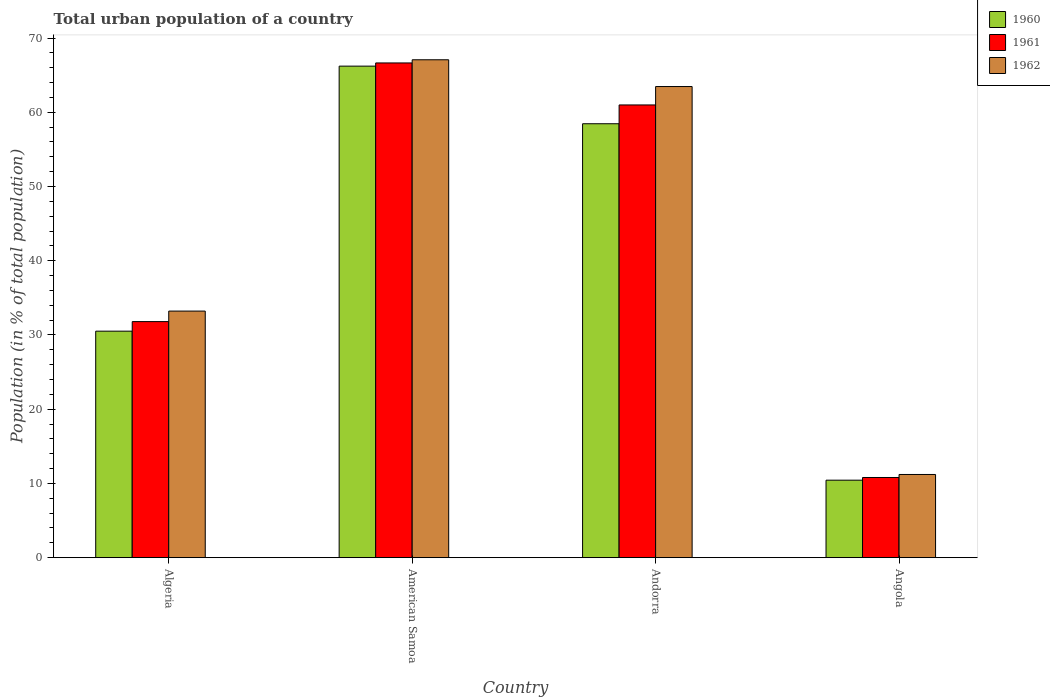How many different coloured bars are there?
Ensure brevity in your answer.  3. How many groups of bars are there?
Make the answer very short. 4. Are the number of bars per tick equal to the number of legend labels?
Your response must be concise. Yes. Are the number of bars on each tick of the X-axis equal?
Keep it short and to the point. Yes. How many bars are there on the 1st tick from the left?
Your answer should be compact. 3. What is the label of the 3rd group of bars from the left?
Offer a terse response. Andorra. In how many cases, is the number of bars for a given country not equal to the number of legend labels?
Offer a very short reply. 0. What is the urban population in 1960 in Algeria?
Make the answer very short. 30.51. Across all countries, what is the maximum urban population in 1960?
Your response must be concise. 66.21. Across all countries, what is the minimum urban population in 1962?
Your answer should be compact. 11.2. In which country was the urban population in 1960 maximum?
Your answer should be very brief. American Samoa. In which country was the urban population in 1962 minimum?
Keep it short and to the point. Angola. What is the total urban population in 1962 in the graph?
Your answer should be compact. 174.95. What is the difference between the urban population in 1961 in Algeria and that in Angola?
Ensure brevity in your answer.  21. What is the difference between the urban population in 1962 in Andorra and the urban population in 1961 in Algeria?
Offer a terse response. 31.67. What is the average urban population in 1961 per country?
Your response must be concise. 42.55. What is the difference between the urban population of/in 1962 and urban population of/in 1961 in American Samoa?
Ensure brevity in your answer.  0.43. In how many countries, is the urban population in 1961 greater than 50 %?
Your response must be concise. 2. What is the ratio of the urban population in 1961 in Algeria to that in Andorra?
Your answer should be compact. 0.52. What is the difference between the highest and the second highest urban population in 1961?
Make the answer very short. 5.66. What is the difference between the highest and the lowest urban population in 1960?
Provide a succinct answer. 55.78. In how many countries, is the urban population in 1960 greater than the average urban population in 1960 taken over all countries?
Give a very brief answer. 2. What does the 1st bar from the left in Algeria represents?
Your response must be concise. 1960. Is it the case that in every country, the sum of the urban population in 1961 and urban population in 1962 is greater than the urban population in 1960?
Give a very brief answer. Yes. How many countries are there in the graph?
Offer a very short reply. 4. Are the values on the major ticks of Y-axis written in scientific E-notation?
Ensure brevity in your answer.  No. Does the graph contain any zero values?
Provide a short and direct response. No. Where does the legend appear in the graph?
Offer a very short reply. Top right. How many legend labels are there?
Make the answer very short. 3. What is the title of the graph?
Your answer should be very brief. Total urban population of a country. Does "1994" appear as one of the legend labels in the graph?
Provide a short and direct response. No. What is the label or title of the Y-axis?
Your response must be concise. Population (in % of total population). What is the Population (in % of total population) in 1960 in Algeria?
Offer a very short reply. 30.51. What is the Population (in % of total population) of 1961 in Algeria?
Offer a terse response. 31.8. What is the Population (in % of total population) of 1962 in Algeria?
Make the answer very short. 33.21. What is the Population (in % of total population) of 1960 in American Samoa?
Provide a short and direct response. 66.21. What is the Population (in % of total population) of 1961 in American Samoa?
Offer a terse response. 66.64. What is the Population (in % of total population) in 1962 in American Samoa?
Provide a succinct answer. 67.07. What is the Population (in % of total population) in 1960 in Andorra?
Give a very brief answer. 58.45. What is the Population (in % of total population) in 1961 in Andorra?
Your response must be concise. 60.98. What is the Population (in % of total population) of 1962 in Andorra?
Provide a succinct answer. 63.46. What is the Population (in % of total population) of 1960 in Angola?
Your answer should be compact. 10.44. What is the Population (in % of total population) in 1961 in Angola?
Ensure brevity in your answer.  10.8. What is the Population (in % of total population) in 1962 in Angola?
Offer a terse response. 11.2. Across all countries, what is the maximum Population (in % of total population) of 1960?
Your response must be concise. 66.21. Across all countries, what is the maximum Population (in % of total population) in 1961?
Ensure brevity in your answer.  66.64. Across all countries, what is the maximum Population (in % of total population) of 1962?
Your answer should be compact. 67.07. Across all countries, what is the minimum Population (in % of total population) of 1960?
Your answer should be compact. 10.44. Across all countries, what is the minimum Population (in % of total population) in 1961?
Ensure brevity in your answer.  10.8. Across all countries, what is the minimum Population (in % of total population) of 1962?
Offer a terse response. 11.2. What is the total Population (in % of total population) of 1960 in the graph?
Make the answer very short. 165.61. What is the total Population (in % of total population) in 1961 in the graph?
Provide a short and direct response. 170.22. What is the total Population (in % of total population) in 1962 in the graph?
Make the answer very short. 174.95. What is the difference between the Population (in % of total population) of 1960 in Algeria and that in American Samoa?
Provide a succinct answer. -35.7. What is the difference between the Population (in % of total population) in 1961 in Algeria and that in American Samoa?
Your answer should be very brief. -34.84. What is the difference between the Population (in % of total population) of 1962 in Algeria and that in American Samoa?
Your answer should be very brief. -33.85. What is the difference between the Population (in % of total population) in 1960 in Algeria and that in Andorra?
Offer a very short reply. -27.94. What is the difference between the Population (in % of total population) of 1961 in Algeria and that in Andorra?
Ensure brevity in your answer.  -29.19. What is the difference between the Population (in % of total population) in 1962 in Algeria and that in Andorra?
Give a very brief answer. -30.25. What is the difference between the Population (in % of total population) in 1960 in Algeria and that in Angola?
Your answer should be compact. 20.07. What is the difference between the Population (in % of total population) in 1961 in Algeria and that in Angola?
Offer a very short reply. 21. What is the difference between the Population (in % of total population) in 1962 in Algeria and that in Angola?
Offer a very short reply. 22.01. What is the difference between the Population (in % of total population) in 1960 in American Samoa and that in Andorra?
Give a very brief answer. 7.76. What is the difference between the Population (in % of total population) of 1961 in American Samoa and that in Andorra?
Your answer should be compact. 5.66. What is the difference between the Population (in % of total population) of 1962 in American Samoa and that in Andorra?
Provide a short and direct response. 3.61. What is the difference between the Population (in % of total population) of 1960 in American Samoa and that in Angola?
Keep it short and to the point. 55.78. What is the difference between the Population (in % of total population) of 1961 in American Samoa and that in Angola?
Your response must be concise. 55.84. What is the difference between the Population (in % of total population) in 1962 in American Samoa and that in Angola?
Your response must be concise. 55.86. What is the difference between the Population (in % of total population) of 1960 in Andorra and that in Angola?
Offer a terse response. 48.02. What is the difference between the Population (in % of total population) of 1961 in Andorra and that in Angola?
Offer a terse response. 50.19. What is the difference between the Population (in % of total population) of 1962 in Andorra and that in Angola?
Make the answer very short. 52.26. What is the difference between the Population (in % of total population) in 1960 in Algeria and the Population (in % of total population) in 1961 in American Samoa?
Give a very brief answer. -36.13. What is the difference between the Population (in % of total population) in 1960 in Algeria and the Population (in % of total population) in 1962 in American Samoa?
Your answer should be very brief. -36.56. What is the difference between the Population (in % of total population) in 1961 in Algeria and the Population (in % of total population) in 1962 in American Samoa?
Your response must be concise. -35.27. What is the difference between the Population (in % of total population) in 1960 in Algeria and the Population (in % of total population) in 1961 in Andorra?
Give a very brief answer. -30.47. What is the difference between the Population (in % of total population) in 1960 in Algeria and the Population (in % of total population) in 1962 in Andorra?
Ensure brevity in your answer.  -32.95. What is the difference between the Population (in % of total population) of 1961 in Algeria and the Population (in % of total population) of 1962 in Andorra?
Your response must be concise. -31.66. What is the difference between the Population (in % of total population) in 1960 in Algeria and the Population (in % of total population) in 1961 in Angola?
Ensure brevity in your answer.  19.71. What is the difference between the Population (in % of total population) in 1960 in Algeria and the Population (in % of total population) in 1962 in Angola?
Offer a very short reply. 19.31. What is the difference between the Population (in % of total population) in 1961 in Algeria and the Population (in % of total population) in 1962 in Angola?
Ensure brevity in your answer.  20.59. What is the difference between the Population (in % of total population) of 1960 in American Samoa and the Population (in % of total population) of 1961 in Andorra?
Offer a terse response. 5.23. What is the difference between the Population (in % of total population) in 1960 in American Samoa and the Population (in % of total population) in 1962 in Andorra?
Your answer should be very brief. 2.75. What is the difference between the Population (in % of total population) in 1961 in American Samoa and the Population (in % of total population) in 1962 in Andorra?
Offer a terse response. 3.18. What is the difference between the Population (in % of total population) in 1960 in American Samoa and the Population (in % of total population) in 1961 in Angola?
Keep it short and to the point. 55.41. What is the difference between the Population (in % of total population) of 1960 in American Samoa and the Population (in % of total population) of 1962 in Angola?
Give a very brief answer. 55.01. What is the difference between the Population (in % of total population) in 1961 in American Samoa and the Population (in % of total population) in 1962 in Angola?
Your answer should be compact. 55.44. What is the difference between the Population (in % of total population) in 1960 in Andorra and the Population (in % of total population) in 1961 in Angola?
Give a very brief answer. 47.65. What is the difference between the Population (in % of total population) in 1960 in Andorra and the Population (in % of total population) in 1962 in Angola?
Your answer should be very brief. 47.25. What is the difference between the Population (in % of total population) in 1961 in Andorra and the Population (in % of total population) in 1962 in Angola?
Make the answer very short. 49.78. What is the average Population (in % of total population) of 1960 per country?
Provide a short and direct response. 41.4. What is the average Population (in % of total population) of 1961 per country?
Provide a short and direct response. 42.55. What is the average Population (in % of total population) of 1962 per country?
Offer a terse response. 43.74. What is the difference between the Population (in % of total population) in 1960 and Population (in % of total population) in 1961 in Algeria?
Keep it short and to the point. -1.29. What is the difference between the Population (in % of total population) of 1960 and Population (in % of total population) of 1962 in Algeria?
Make the answer very short. -2.7. What is the difference between the Population (in % of total population) of 1961 and Population (in % of total population) of 1962 in Algeria?
Provide a succinct answer. -1.42. What is the difference between the Population (in % of total population) of 1960 and Population (in % of total population) of 1961 in American Samoa?
Your response must be concise. -0.43. What is the difference between the Population (in % of total population) in 1960 and Population (in % of total population) in 1962 in American Samoa?
Provide a succinct answer. -0.86. What is the difference between the Population (in % of total population) of 1961 and Population (in % of total population) of 1962 in American Samoa?
Make the answer very short. -0.43. What is the difference between the Population (in % of total population) in 1960 and Population (in % of total population) in 1961 in Andorra?
Make the answer very short. -2.53. What is the difference between the Population (in % of total population) of 1960 and Population (in % of total population) of 1962 in Andorra?
Offer a terse response. -5.01. What is the difference between the Population (in % of total population) in 1961 and Population (in % of total population) in 1962 in Andorra?
Offer a very short reply. -2.48. What is the difference between the Population (in % of total population) in 1960 and Population (in % of total population) in 1961 in Angola?
Offer a terse response. -0.36. What is the difference between the Population (in % of total population) in 1960 and Population (in % of total population) in 1962 in Angola?
Offer a terse response. -0.77. What is the difference between the Population (in % of total population) of 1961 and Population (in % of total population) of 1962 in Angola?
Offer a terse response. -0.41. What is the ratio of the Population (in % of total population) of 1960 in Algeria to that in American Samoa?
Ensure brevity in your answer.  0.46. What is the ratio of the Population (in % of total population) of 1961 in Algeria to that in American Samoa?
Offer a terse response. 0.48. What is the ratio of the Population (in % of total population) of 1962 in Algeria to that in American Samoa?
Provide a short and direct response. 0.5. What is the ratio of the Population (in % of total population) in 1960 in Algeria to that in Andorra?
Offer a very short reply. 0.52. What is the ratio of the Population (in % of total population) in 1961 in Algeria to that in Andorra?
Make the answer very short. 0.52. What is the ratio of the Population (in % of total population) in 1962 in Algeria to that in Andorra?
Keep it short and to the point. 0.52. What is the ratio of the Population (in % of total population) in 1960 in Algeria to that in Angola?
Ensure brevity in your answer.  2.92. What is the ratio of the Population (in % of total population) of 1961 in Algeria to that in Angola?
Keep it short and to the point. 2.94. What is the ratio of the Population (in % of total population) of 1962 in Algeria to that in Angola?
Ensure brevity in your answer.  2.96. What is the ratio of the Population (in % of total population) in 1960 in American Samoa to that in Andorra?
Offer a very short reply. 1.13. What is the ratio of the Population (in % of total population) in 1961 in American Samoa to that in Andorra?
Offer a terse response. 1.09. What is the ratio of the Population (in % of total population) in 1962 in American Samoa to that in Andorra?
Make the answer very short. 1.06. What is the ratio of the Population (in % of total population) in 1960 in American Samoa to that in Angola?
Your answer should be very brief. 6.35. What is the ratio of the Population (in % of total population) of 1961 in American Samoa to that in Angola?
Your answer should be compact. 6.17. What is the ratio of the Population (in % of total population) in 1962 in American Samoa to that in Angola?
Your answer should be very brief. 5.99. What is the ratio of the Population (in % of total population) of 1960 in Andorra to that in Angola?
Offer a very short reply. 5.6. What is the ratio of the Population (in % of total population) of 1961 in Andorra to that in Angola?
Offer a terse response. 5.65. What is the ratio of the Population (in % of total population) in 1962 in Andorra to that in Angola?
Provide a succinct answer. 5.66. What is the difference between the highest and the second highest Population (in % of total population) in 1960?
Provide a short and direct response. 7.76. What is the difference between the highest and the second highest Population (in % of total population) in 1961?
Make the answer very short. 5.66. What is the difference between the highest and the second highest Population (in % of total population) in 1962?
Keep it short and to the point. 3.61. What is the difference between the highest and the lowest Population (in % of total population) in 1960?
Offer a very short reply. 55.78. What is the difference between the highest and the lowest Population (in % of total population) of 1961?
Make the answer very short. 55.84. What is the difference between the highest and the lowest Population (in % of total population) in 1962?
Make the answer very short. 55.86. 